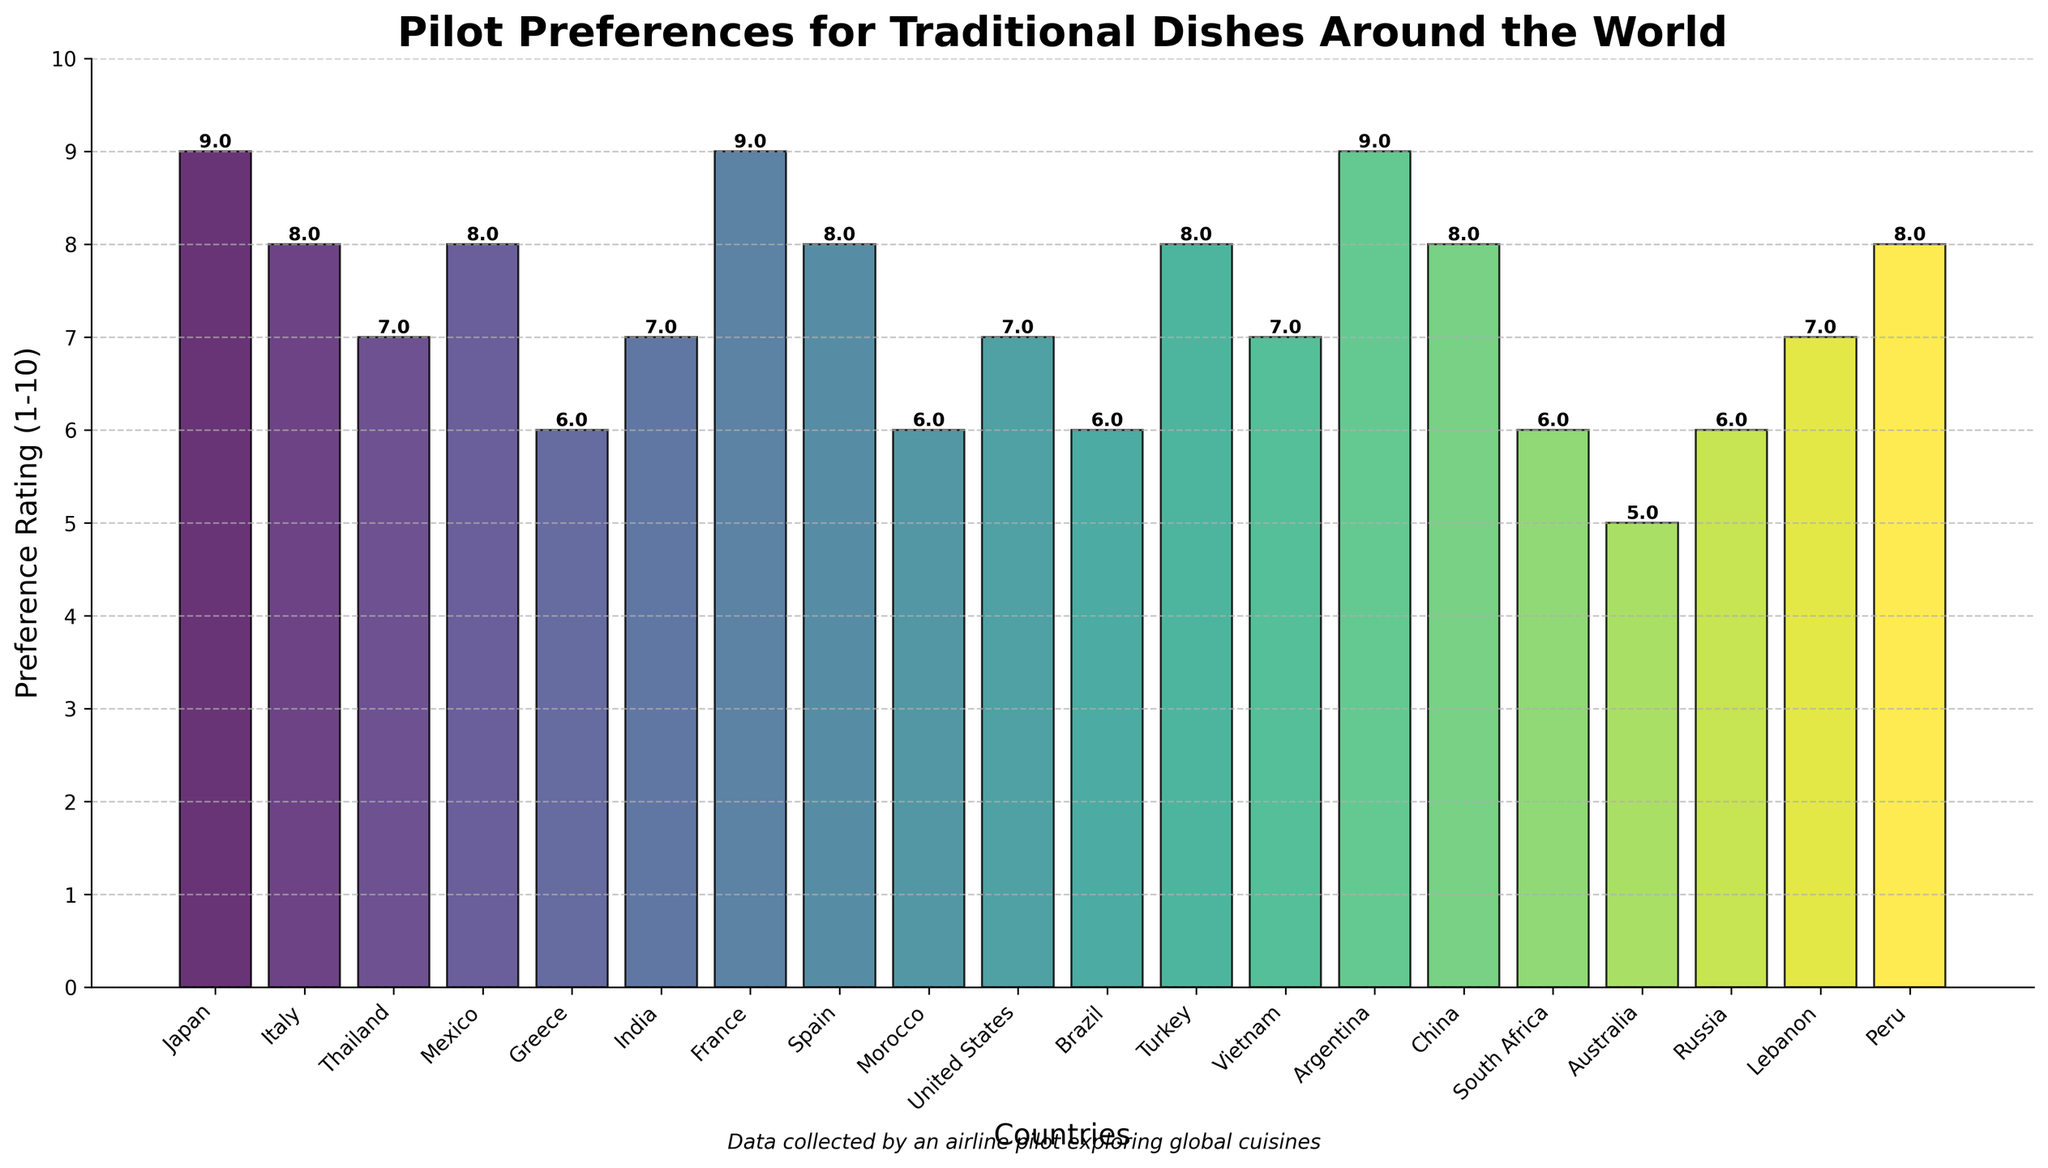Which country’s traditional dish has the highest pilot preference rating? The highest bar in the chart represents the dish with the highest rating. By comparing the heights of all bars, the bar for Japan's Sushi reaches the highest point, indicating the highest rating.
Answer: Japan Which traditional dish received a rating of 5? By looking at the bar that reaches the point for rating 5, it's the bar for Australia’s Meat Pie.
Answer: Meat Pie (Australia) How many traditional dishes have a pilot preference rating of 8 or higher? Identify the bars with heights corresponding to 8 or higher and count them. These dishes are: Sushi (9), Pasta al Pomodoro (8), Tacos al Pastor (8), Pad Thai (8), Coq au Vin (9), Paella (8), Kebab (8), Asado (9), Peking Duck (8), Ceviche (8).
Answer: 10 Compare the ratings of Greece's Moussaka and Morocco's Tagine. Which one is higher? Look at the bars for Greece and Morocco. Moussaka has a rating of 6, and Tagine also has a rating of 6. Therefore, both have the same rating.
Answer: Same What is the average rating of all the traditional dishes in the chart? Add the ratings of all dishes together and then divide by the number of dishes. The sum is \(9 + 8 + 7 + 8 + 6 + 7 + 9 + 8 + 6 + 7 + 6 + 8 + 7 + 9 + 8 + 6 + 5 + 6 + 7 + 8 = 139\). There are 20 dishes. The average rating is \( \frac{139}{20} = 6.95 \).
Answer: 6.95 Which region has more dishes with a rating of 9, Asia or South America? Identify the dishes with a rating of 9: Sushi (Japan) and Coq au Vin (France), plus Asado (Argentina). Since only Argentina (in South America) has a dish rated 9, and Japan is in Asia, Asia has more dishes rated 9.
Answer: Asia Which traditional dish from the graph has a preference rating equal to its index in the sorted list of countries? Notice that the rating matches the index number (starting from 1) in the list of 20 countries. Italy's Pasta al Pomodoro is at position 8 in the list and has a rating of 8.
Answer: Pasta al Pomodoro (Italy) What is the total rating for dishes that received a score of 7? Sum the ratings for dishes marked as 7: Pad Thai (Thailand), Butter Chicken (India), BBQ Ribs (United States), Pho (Vietnam), and Kibbeh (Lebanon). So it's \( 7 + 7 + 7 + 7 + 7 = 35 \).
Answer: 35 Which country’s traditional dish has the same preference rating as Feijoada from Brazil? Find the preference rating for Brazil’s Feijoada which is 6. Other dishes with the same rating are Moussaka (Greece), Tagine (Morocco), Borscht (Russia), and Bobotie (South Africa).
Answer: Moussaka (Greece), Tagine (Morocco), Borscht (Russia), and Bobotie (South Africa) Which traditional dish received higher pilot preference rating: US BBQ Ribs or France's Coq au Vin? Look at the bars for US BBQ Ribs and France's Coq au Vin. BBQ Ribs has a rating of 7, while Coq au Vin has a rating of 9. So Coq au Vin has a higher rating.
Answer: Coq au Vin (France) 